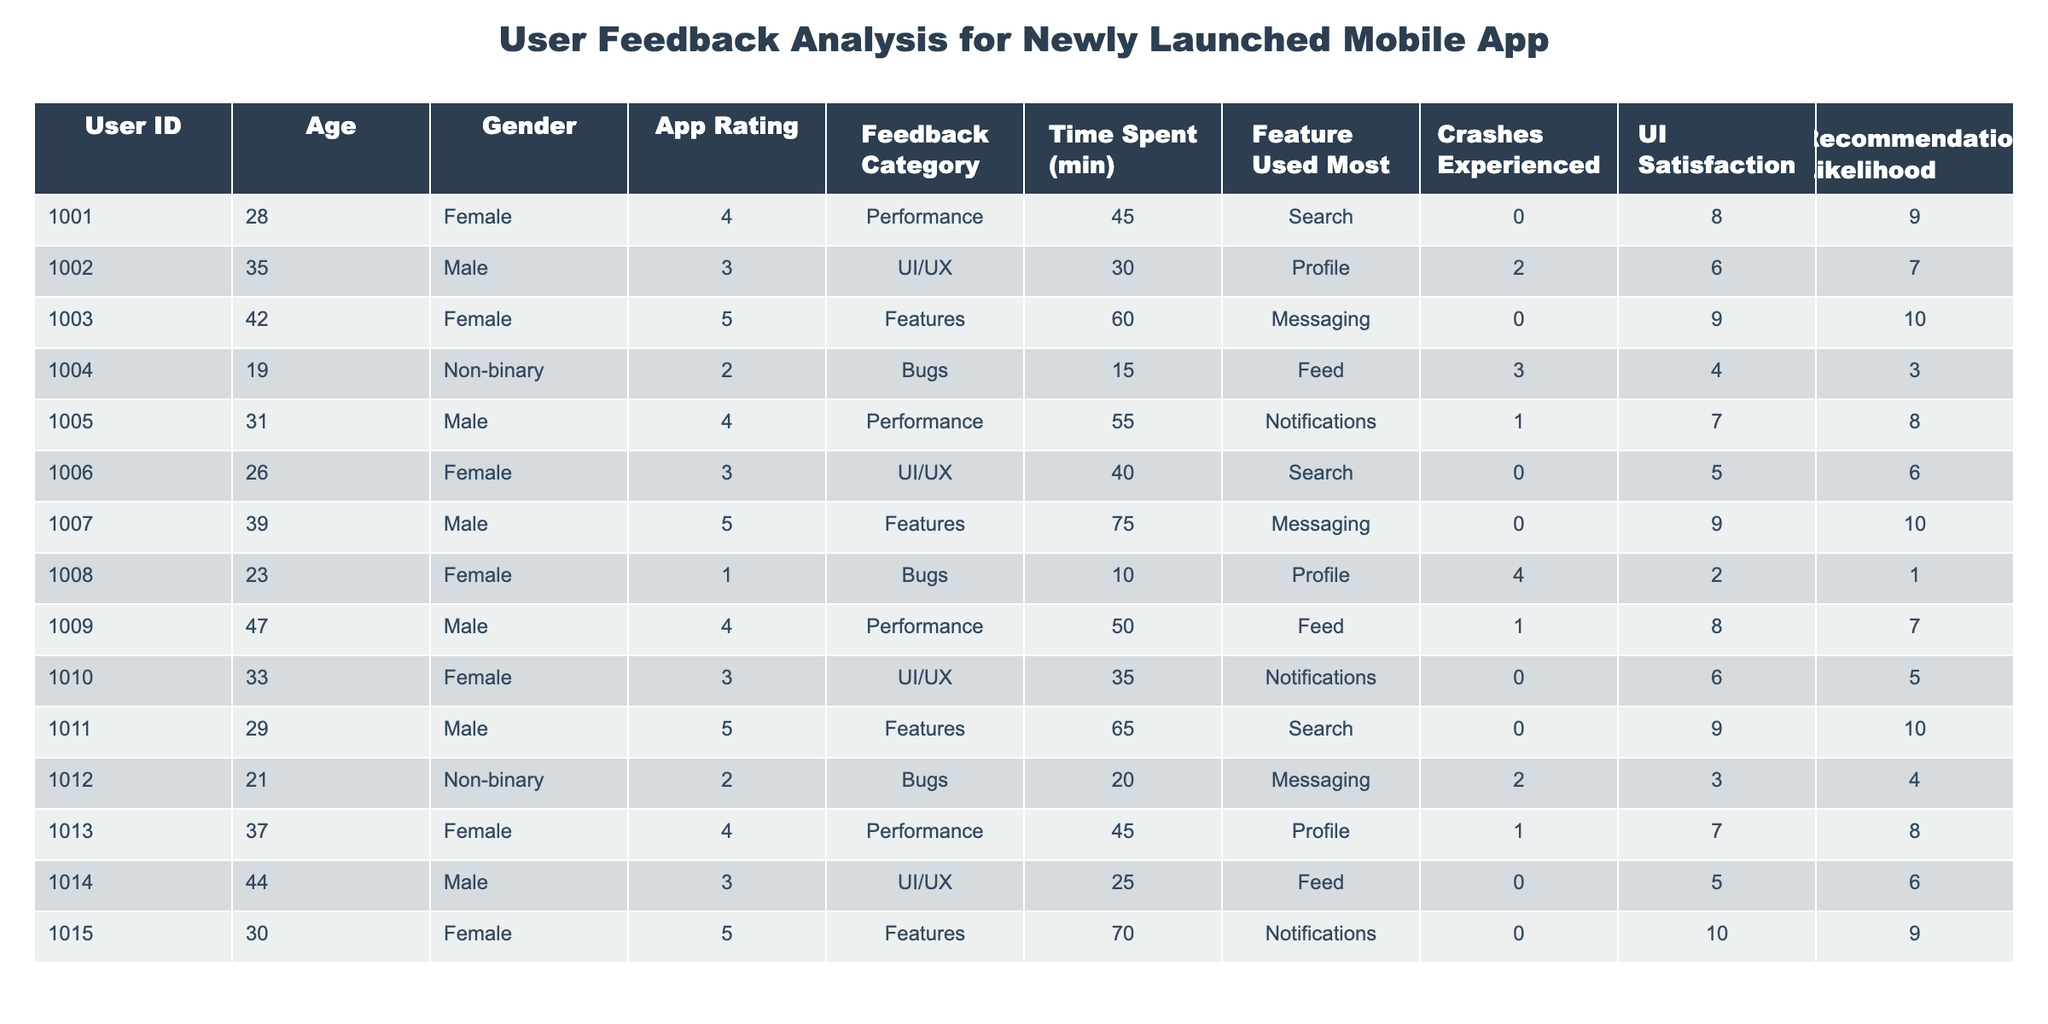What's the average app rating from users? To find the average app rating, we add up all the app ratings: (4 + 3 + 5 + 2 + 4 + 3 + 5 + 1 + 4 + 3 + 5 + 2 + 4 + 3 + 5) = 54. There are 15 users, so we divide 54 by 15 to get an average of 3.6.
Answer: 3.6 How many users experienced crashes? We can count the number of rows where "Crashes Experienced" is greater than 0. There are 5 users (IDs 1002, 1004, 1008, 1012) that experienced crashes.
Answer: 4 Is there any user with a UI satisfaction score of 10? By looking through the "UI Satisfaction" column, we see that User ID 1015 has a score of 10.
Answer: Yes What percentage of users rated the app 4 or above? To find this, we need to count how many users rated the app 4 or above (9 users) and then divide that number by the total number of users (15), then multiply by 100. (9/15) * 100 = 60%.
Answer: 60% What feature did the user with ID 1008 use most? According to the table, User ID 1008 used the "Profile" feature most frequently.
Answer: Profile What is the average time spent by users who reported bugs? We look at the "Time Spent (min)" for users who reported bugs (IDs 1004, 1008, 1012). Their times are 15, 10, and 20 minutes respectively. Add them up: 15 + 10 + 20 = 45. There are 3 of them, so the average is 45 / 3 = 15.
Answer: 15 Among users who spent more than 50 minutes on the app, what is the average recommendation likelihood? Users who spent more than 50 minutes (IDs 1003, 1007, 1011, 1015) have recommendation likelihoods of 10, 10, 10, and 9 respectively. The sum is 10 + 10 + 10 + 9 = 39. There are 4 users, so the average is 39 / 4 = 9.75.
Answer: 9.75 Which gender has the highest average app rating? We separate users by gender. For Female: (4+5+3+5+5) = 22 / 6 = 4. For Male: (3+4+5+4+3) = 19 / 5 = 3.8. Non-binary had ratings of 2, which is lower than both. Female has the highest average app rating of 4.
Answer: Female What is the maximum score for recommendation likelihood from users who primarily used the "Messaging" feature? Looking at the users who primarily used "Messaging" (IDs 1003, 1007, 1012), their recommendation likelihoods are 10, 10, and 4 respectively. The maximum of these values is 10.
Answer: 10 